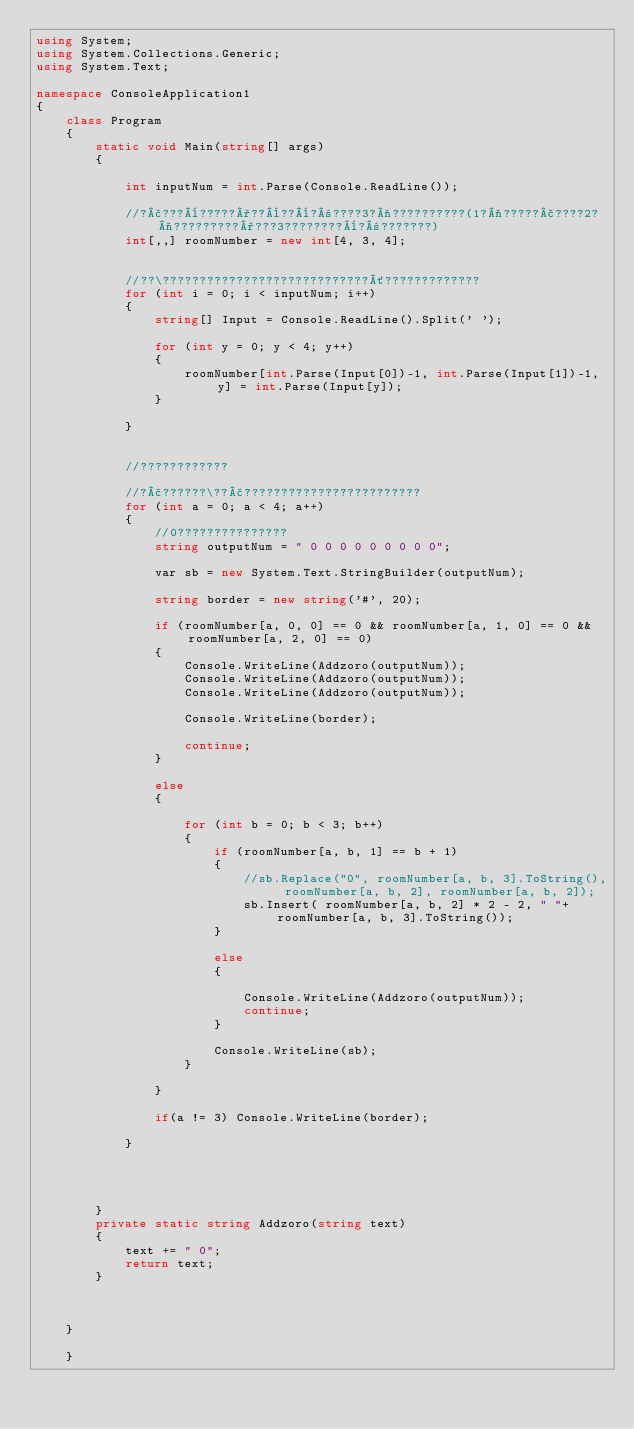Convert code to text. <code><loc_0><loc_0><loc_500><loc_500><_C#_>using System;
using System.Collections.Generic;
using System.Text;

namespace ConsoleApplication1
{
    class Program
    {
        static void Main(string[] args)
        {

            int inputNum = int.Parse(Console.ReadLine());

            //?£???¨?????°??¨??¨?±????3?¬??????????(1?¬?????£????2?¬?????????°???3????????¨?±???????)
            int[,,] roomNumber = new int[4, 3, 4];


            //??\????????????????????????????´?????????????
            for (int i = 0; i < inputNum; i++)
            {
                string[] Input = Console.ReadLine().Split(' ');

                for (int y = 0; y < 4; y++)
                {
                    roomNumber[int.Parse(Input[0])-1, int.Parse(Input[1])-1, y] = int.Parse(Input[y]);
                }

            }


            //????????????

            //?£??????\??£????????????????????????
            for (int a = 0; a < 4; a++)
            {
                //0???????????????
                string outputNum = " 0 0 0 0 0 0 0 0 0";

                var sb = new System.Text.StringBuilder(outputNum);

                string border = new string('#', 20);

                if (roomNumber[a, 0, 0] == 0 && roomNumber[a, 1, 0] == 0 && roomNumber[a, 2, 0] == 0)
                {
                    Console.WriteLine(Addzoro(outputNum));
                    Console.WriteLine(Addzoro(outputNum));
                    Console.WriteLine(Addzoro(outputNum));

                    Console.WriteLine(border);

                    continue;
                }

                else
                {

                    for (int b = 0; b < 3; b++)
                    {
                        if (roomNumber[a, b, 1] == b + 1)
                        {
                            //sb.Replace("0", roomNumber[a, b, 3].ToString(), roomNumber[a, b, 2], roomNumber[a, b, 2]);
                            sb.Insert( roomNumber[a, b, 2] * 2 - 2, " "+roomNumber[a, b, 3].ToString());
                        }

                        else
                        {

                            Console.WriteLine(Addzoro(outputNum));
                            continue;
                        }

                        Console.WriteLine(sb);
                    }

                }

                if(a != 3) Console.WriteLine(border);

            }




        }
        private static string Addzoro(string text)
        {
            text += " 0";
            return text;
        }



    }

    }</code> 